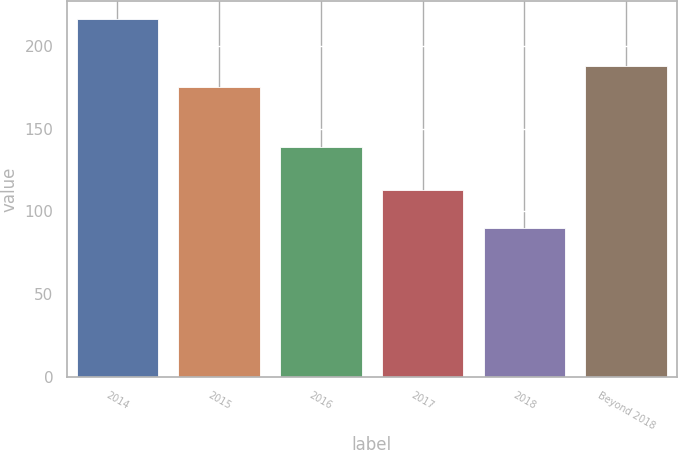Convert chart to OTSL. <chart><loc_0><loc_0><loc_500><loc_500><bar_chart><fcel>2014<fcel>2015<fcel>2016<fcel>2017<fcel>2018<fcel>Beyond 2018<nl><fcel>216<fcel>175<fcel>139<fcel>113<fcel>90<fcel>187.6<nl></chart> 